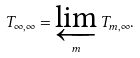<formula> <loc_0><loc_0><loc_500><loc_500>T _ { \infty , \infty } = \varprojlim _ { m } T _ { m , \infty } .</formula> 